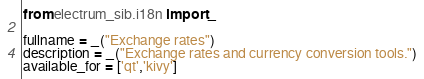Convert code to text. <code><loc_0><loc_0><loc_500><loc_500><_Python_>from electrum_sib.i18n import _

fullname = _("Exchange rates")
description = _("Exchange rates and currency conversion tools.")
available_for = ['qt','kivy']
</code> 